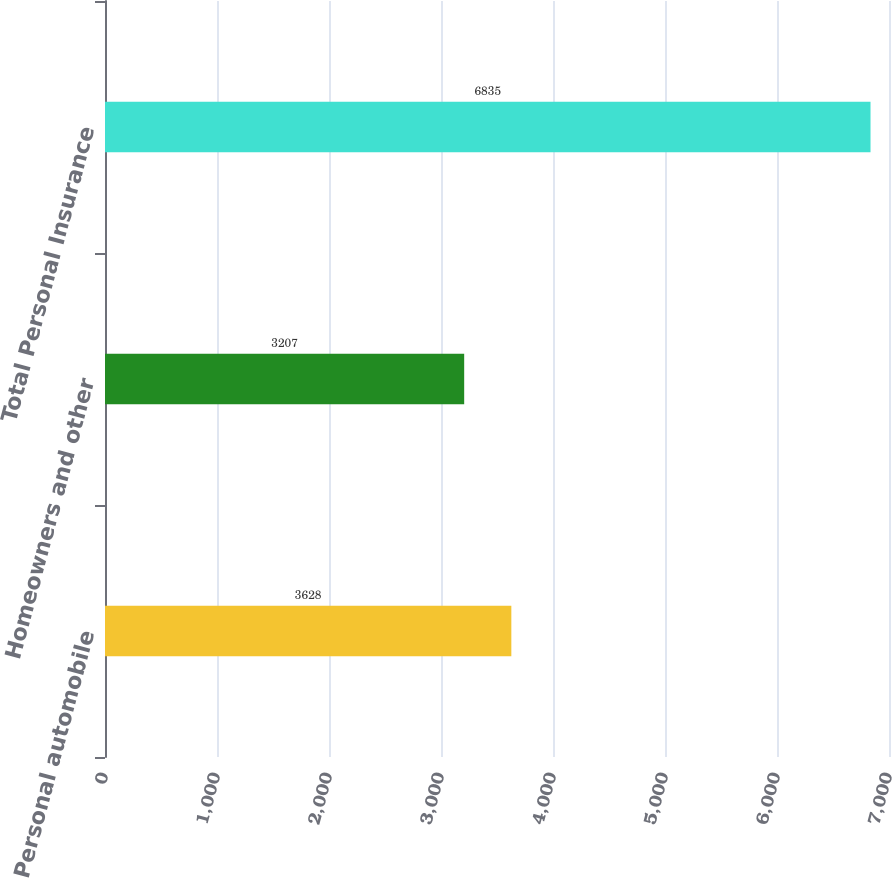Convert chart. <chart><loc_0><loc_0><loc_500><loc_500><bar_chart><fcel>Personal automobile<fcel>Homeowners and other<fcel>Total Personal Insurance<nl><fcel>3628<fcel>3207<fcel>6835<nl></chart> 